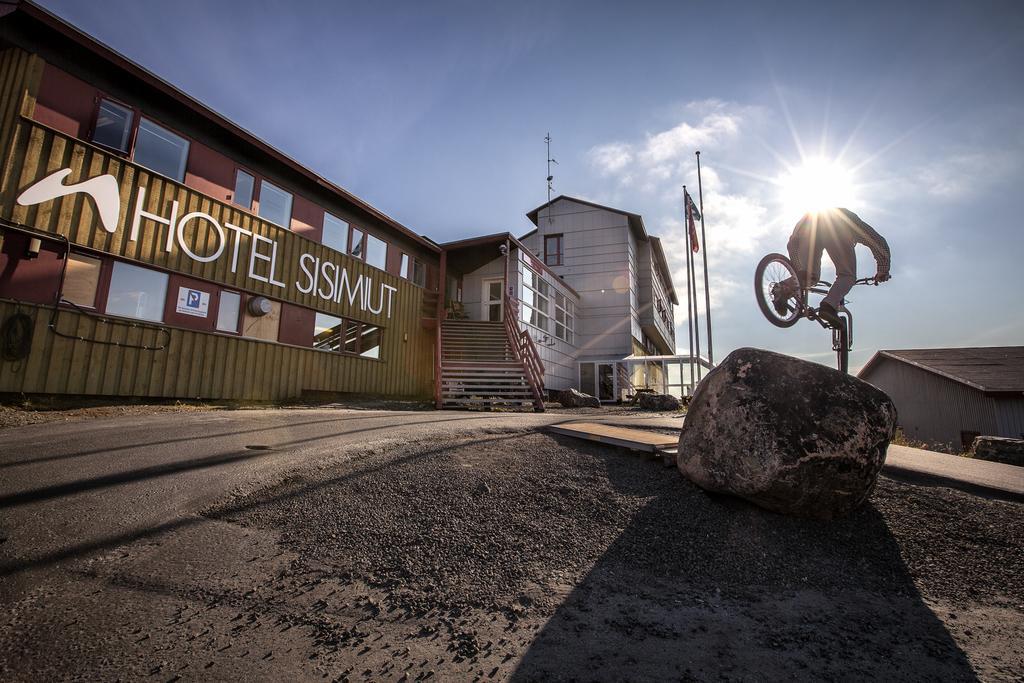How would you summarize this image in a sentence or two? There is a stone. And a person on a cycle is jumping. In the back there are flags with poles. On the left side there are buildings with windows. Also there are steps with railings. In the background there is sky with clouds. On the side there is another building. 